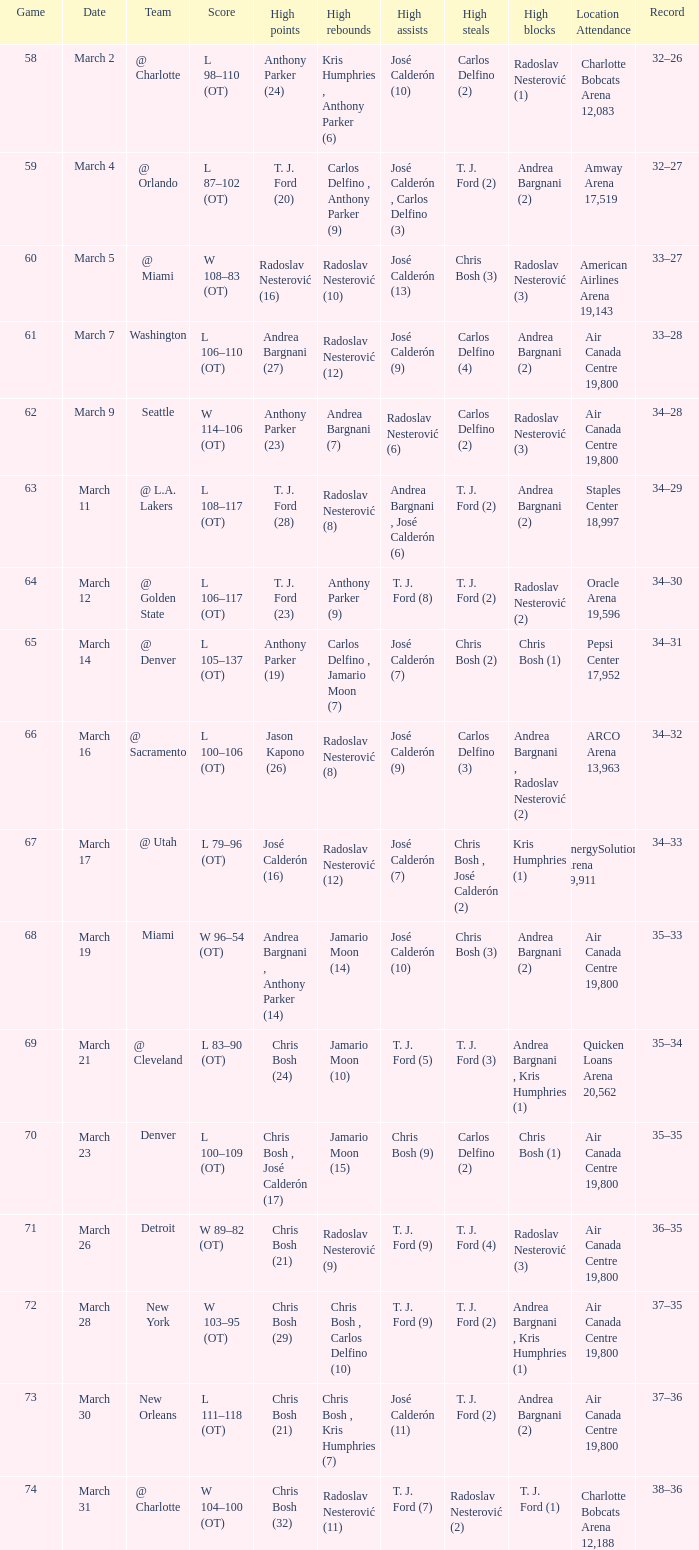How many attended the game on march 16 after over 64 games? ARCO Arena 13,963. Can you give me this table as a dict? {'header': ['Game', 'Date', 'Team', 'Score', 'High points', 'High rebounds', 'High assists', 'High steals', 'High blocks', 'Location Attendance', 'Record'], 'rows': [['58', 'March 2', '@ Charlotte', 'L 98–110 (OT)', 'Anthony Parker (24)', 'Kris Humphries , Anthony Parker (6)', 'José Calderón (10)', 'Carlos Delfino (2)', 'Radoslav Nesterović (1)', 'Charlotte Bobcats Arena 12,083', '32–26'], ['59', 'March 4', '@ Orlando', 'L 87–102 (OT)', 'T. J. Ford (20)', 'Carlos Delfino , Anthony Parker (9)', 'José Calderón , Carlos Delfino (3)', 'T. J. Ford (2)', 'Andrea Bargnani (2)', 'Amway Arena 17,519', '32–27'], ['60', 'March 5', '@ Miami', 'W 108–83 (OT)', 'Radoslav Nesterović (16)', 'Radoslav Nesterović (10)', 'José Calderón (13)', 'Chris Bosh (3)', 'Radoslav Nesterović (3)', 'American Airlines Arena 19,143', '33–27'], ['61', 'March 7', 'Washington', 'L 106–110 (OT)', 'Andrea Bargnani (27)', 'Radoslav Nesterović (12)', 'José Calderón (9)', 'Carlos Delfino (4)', 'Andrea Bargnani (2)', 'Air Canada Centre 19,800', '33–28'], ['62', 'March 9', 'Seattle', 'W 114–106 (OT)', 'Anthony Parker (23)', 'Andrea Bargnani (7)', 'Radoslav Nesterović (6)', 'Carlos Delfino (2)', 'Radoslav Nesterović (3)', 'Air Canada Centre 19,800', '34–28'], ['63', 'March 11', '@ L.A. Lakers', 'L 108–117 (OT)', 'T. J. Ford (28)', 'Radoslav Nesterović (8)', 'Andrea Bargnani , José Calderón (6)', 'T. J. Ford (2)', 'Andrea Bargnani (2)', 'Staples Center 18,997', '34–29'], ['64', 'March 12', '@ Golden State', 'L 106–117 (OT)', 'T. J. Ford (23)', 'Anthony Parker (9)', 'T. J. Ford (8)', 'T. J. Ford (2)', 'Radoslav Nesterović (2)', 'Oracle Arena 19,596', '34–30'], ['65', 'March 14', '@ Denver', 'L 105–137 (OT)', 'Anthony Parker (19)', 'Carlos Delfino , Jamario Moon (7)', 'José Calderón (7)', 'Chris Bosh (2)', 'Chris Bosh (1)', 'Pepsi Center 17,952', '34–31'], ['66', 'March 16', '@ Sacramento', 'L 100–106 (OT)', 'Jason Kapono (26)', 'Radoslav Nesterović (8)', 'José Calderón (9)', 'Carlos Delfino (3)', 'Andrea Bargnani , Radoslav Nesterović (2)', 'ARCO Arena 13,963', '34–32'], ['67', 'March 17', '@ Utah', 'L 79–96 (OT)', 'José Calderón (16)', 'Radoslav Nesterović (12)', 'José Calderón (7)', 'Chris Bosh , José Calderón (2)', 'Kris Humphries (1)', 'EnergySolutions Arena 19,911', '34–33'], ['68', 'March 19', 'Miami', 'W 96–54 (OT)', 'Andrea Bargnani , Anthony Parker (14)', 'Jamario Moon (14)', 'José Calderón (10)', 'Chris Bosh (3)', 'Andrea Bargnani (2)', 'Air Canada Centre 19,800', '35–33'], ['69', 'March 21', '@ Cleveland', 'L 83–90 (OT)', 'Chris Bosh (24)', 'Jamario Moon (10)', 'T. J. Ford (5)', 'T. J. Ford (3)', 'Andrea Bargnani , Kris Humphries (1)', 'Quicken Loans Arena 20,562', '35–34'], ['70', 'March 23', 'Denver', 'L 100–109 (OT)', 'Chris Bosh , José Calderón (17)', 'Jamario Moon (15)', 'Chris Bosh (9)', 'Carlos Delfino (2)', 'Chris Bosh (1)', 'Air Canada Centre 19,800', '35–35'], ['71', 'March 26', 'Detroit', 'W 89–82 (OT)', 'Chris Bosh (21)', 'Radoslav Nesterović (9)', 'T. J. Ford (9)', 'T. J. Ford (4)', 'Radoslav Nesterović (3)', 'Air Canada Centre 19,800', '36–35'], ['72', 'March 28', 'New York', 'W 103–95 (OT)', 'Chris Bosh (29)', 'Chris Bosh , Carlos Delfino (10)', 'T. J. Ford (9)', 'T. J. Ford (2)', 'Andrea Bargnani , Kris Humphries (1)', 'Air Canada Centre 19,800', '37–35'], ['73', 'March 30', 'New Orleans', 'L 111–118 (OT)', 'Chris Bosh (21)', 'Chris Bosh , Kris Humphries (7)', 'José Calderón (11)', 'T. J. Ford (2)', 'Andrea Bargnani (2)', 'Air Canada Centre 19,800', '37–36'], ['74', 'March 31', '@ Charlotte', 'W 104–100 (OT)', 'Chris Bosh (32)', 'Radoslav Nesterović (11)', 'T. J. Ford (7)', 'Radoslav Nesterović (2)', 'T. J. Ford (1)', 'Charlotte Bobcats Arena 12,188', '38–36']]} 